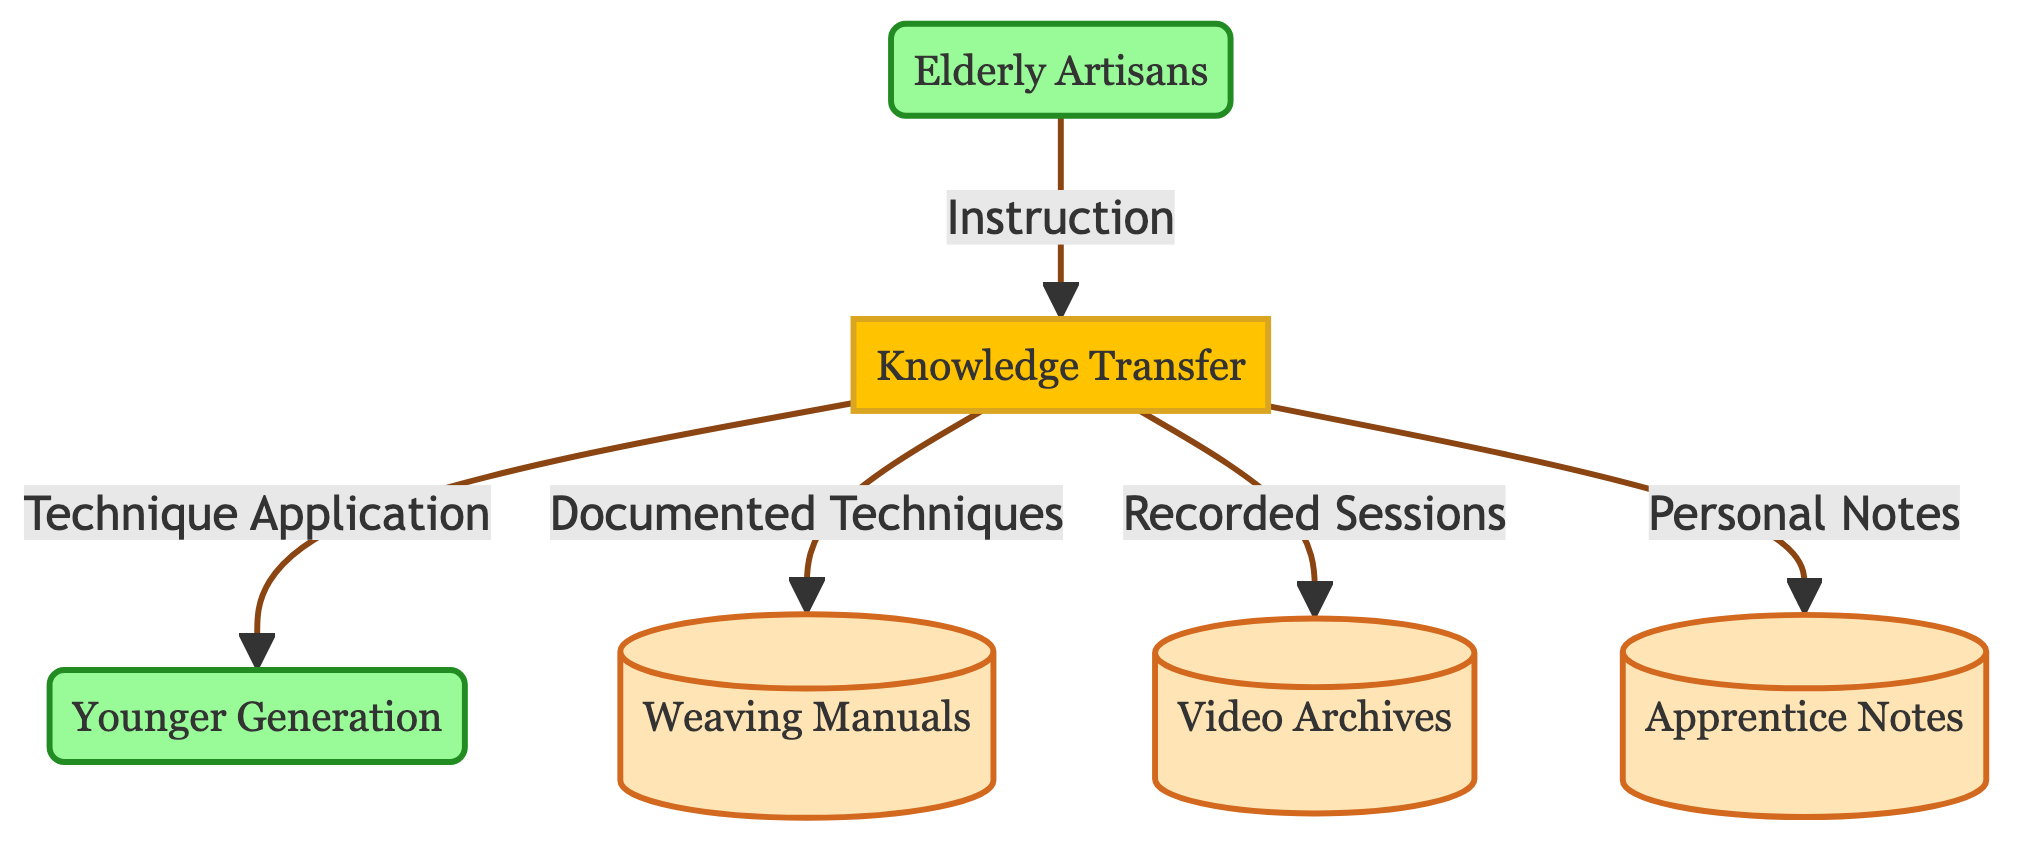What is the main process depicted in the diagram? The diagram depicts the "Knowledge Transfer" process, which is the central focus of the flow. This process involves transferring traditional weaving techniques from elderly artisans to the younger generation.
Answer: Knowledge Transfer How many data stores are included in the diagram? There are three data stores listed in the diagram: Weaving Manuals, Video Archives, and Apprentice Notes. By counting each of these elements, we determine the total number of data stores.
Answer: 3 Who provides the instructions to the knowledge transfer process? The instructions are given by the "Elderly Artisans." They are depicted as the source of the instruction data flow into the knowledge transfer process.
Answer: Elderly Artisans What type of notes do apprentices take during the training sessions? The apprentices take "Personal Notes," which are documented as part of their learning process in the knowledge transfer diagram.
Answer: Personal Notes What is the result of the knowledge transfer process directed towards the younger generation? The knowledge transfer process leads to "Technique Application," as the younger generation learns and applies the weaving techniques. This is the output flow from the knowledge transfer process.
Answer: Technique Application What archival format is used for recorded sessions? The recorded sessions from the knowledge transfer process are stored in the "Video Archives." This indicates a type of data storage related to training.
Answer: Video Archives What type of materials are included in the weaving manuals? The "Weaving Manuals" contain detailed traditional weaving techniques documented for future reference. This suggests that the manuals serve as a comprehensive guide.
Answer: Traditional weaving techniques What originates from the knowledge transfer process and goes directly to the weaving manuals? The flow that originates from the knowledge transfer process and goes to the weaving manuals is called "Documented Techniques." This indicates that techniques learned are documented.
Answer: Documented Techniques What is the relationship between the elderly artisans and the knowledge transfer process? The elderly artisans are the source that provides the required instruction to the knowledge transfer process, initiating the exchange of knowledge.
Answer: Source of instruction 